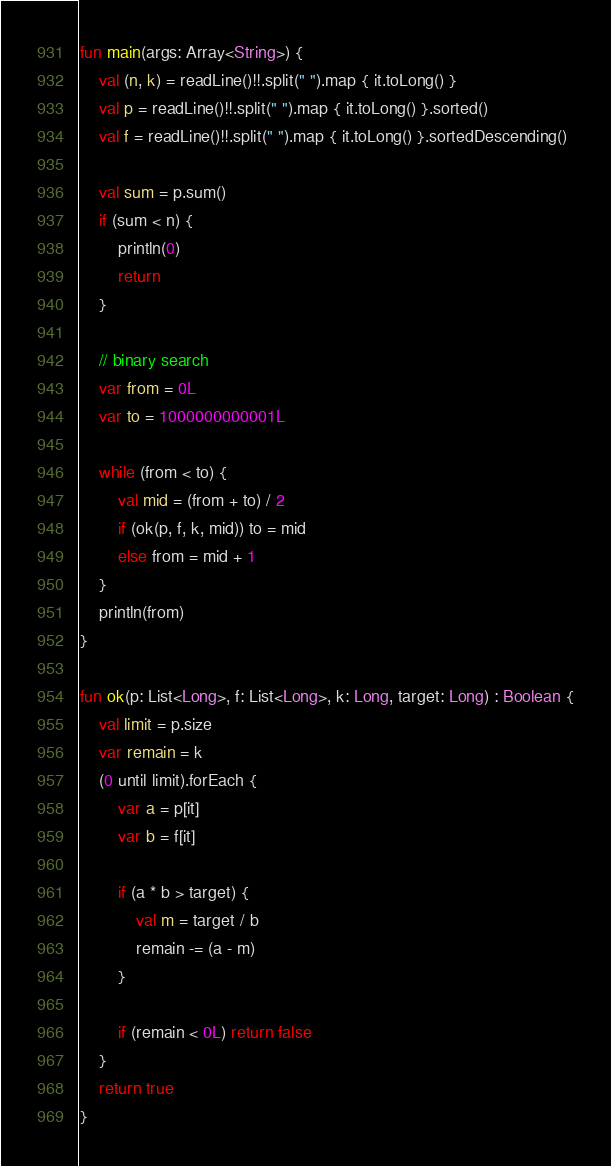Convert code to text. <code><loc_0><loc_0><loc_500><loc_500><_Kotlin_>fun main(args: Array<String>) {
    val (n, k) = readLine()!!.split(" ").map { it.toLong() }
    val p = readLine()!!.split(" ").map { it.toLong() }.sorted()
    val f = readLine()!!.split(" ").map { it.toLong() }.sortedDescending()

    val sum = p.sum()
    if (sum < n) {
        println(0)
        return
    }

    // binary search
    var from = 0L
    var to = 1000000000001L

    while (from < to) {
        val mid = (from + to) / 2
        if (ok(p, f, k, mid)) to = mid
        else from = mid + 1
    }
    println(from)
}

fun ok(p: List<Long>, f: List<Long>, k: Long, target: Long) : Boolean {
    val limit = p.size
    var remain = k
    (0 until limit).forEach {
        var a = p[it]
        var b = f[it]

        if (a * b > target) {
            val m = target / b
            remain -= (a - m)
        }

        if (remain < 0L) return false
    }
    return true
}
</code> 